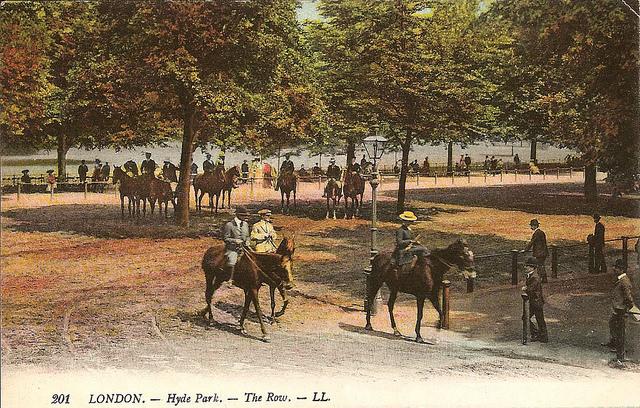Is there a man or woman on the horse in front of the others?
Concise answer only. Woman. Was the image photographed recently?
Answer briefly. No. What city does this postcard depict?
Give a very brief answer. London. 